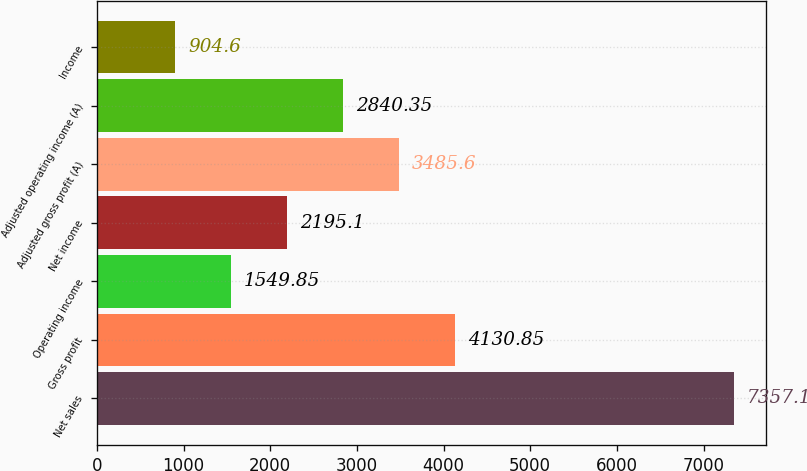Convert chart to OTSL. <chart><loc_0><loc_0><loc_500><loc_500><bar_chart><fcel>Net sales<fcel>Gross profit<fcel>Operating income<fcel>Net income<fcel>Adjusted gross profit (A)<fcel>Adjusted operating income (A)<fcel>Income<nl><fcel>7357.1<fcel>4130.85<fcel>1549.85<fcel>2195.1<fcel>3485.6<fcel>2840.35<fcel>904.6<nl></chart> 